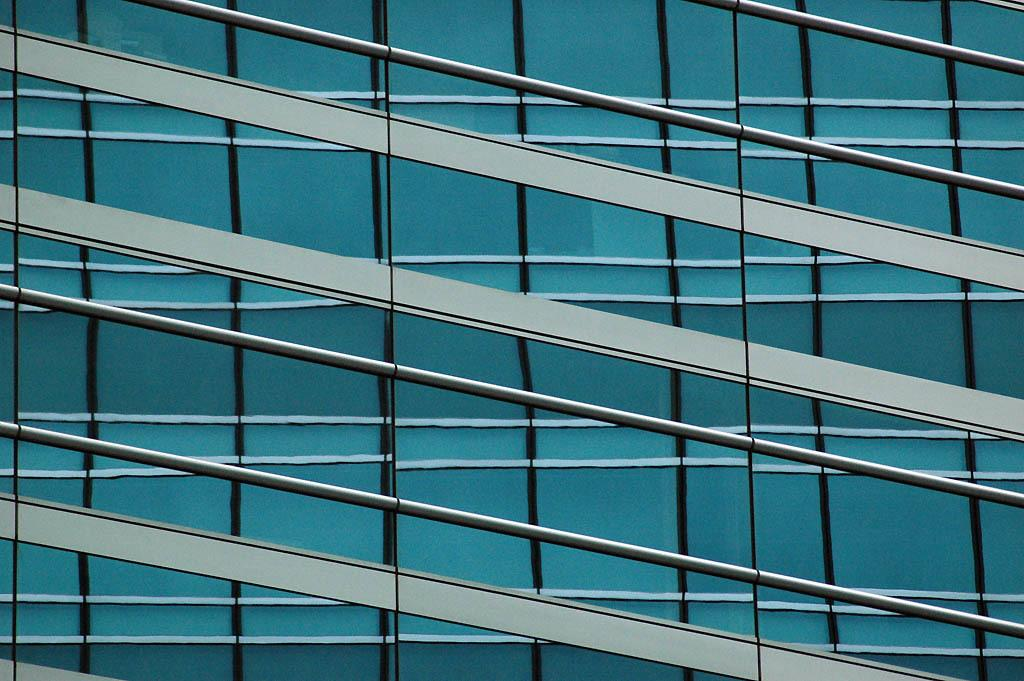What type of structure is visible in the image? There is a building in the image. What feature can be observed on the building? The building has glass windows. What type of popcorn is being served in the building in the image? There is no popcorn present in the image, as it only features a building with glass windows. 